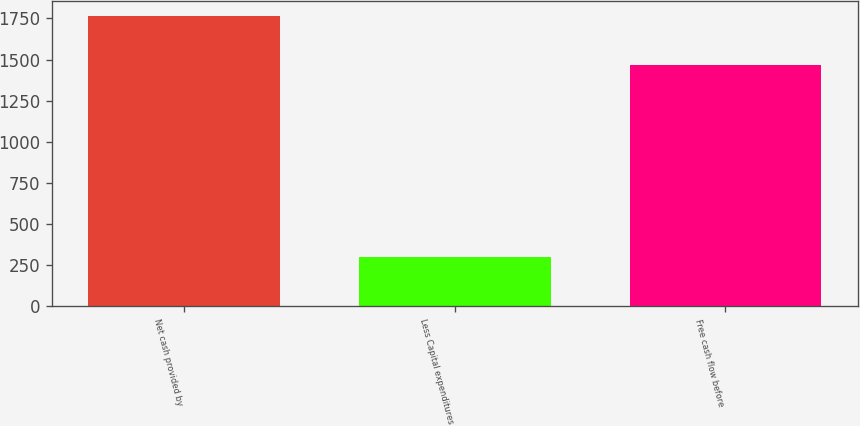<chart> <loc_0><loc_0><loc_500><loc_500><bar_chart><fcel>Net cash provided by<fcel>Less Capital expenditures<fcel>Free cash flow before<nl><fcel>1767.7<fcel>302.1<fcel>1465.6<nl></chart> 